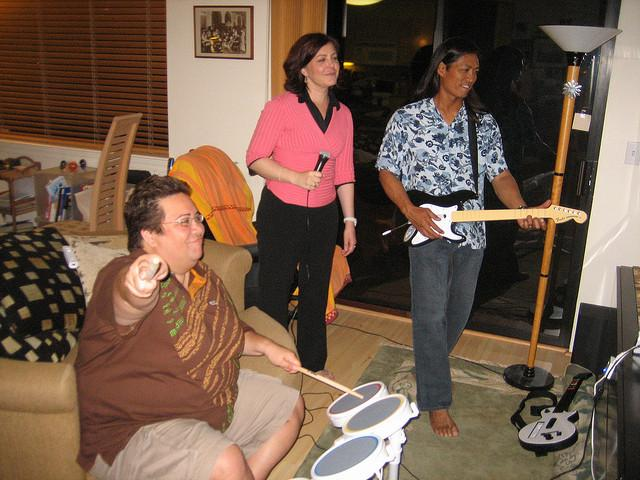What activity is being shared by the people?

Choices:
A) cooking
B) video gaming
C) karaoke
D) live audition video gaming 